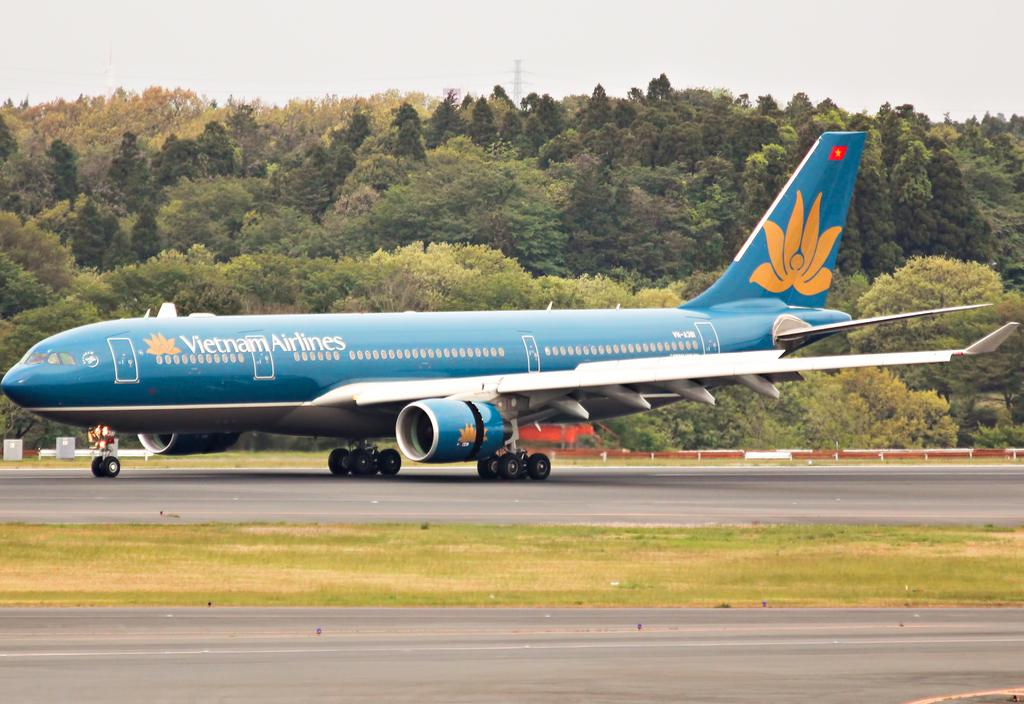Provide a one-sentence caption for the provided image. A Vietnam Airlines plane sits on the runway. 